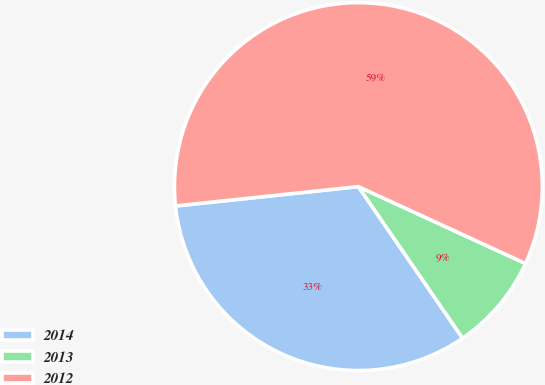Convert chart. <chart><loc_0><loc_0><loc_500><loc_500><pie_chart><fcel>2014<fcel>2013<fcel>2012<nl><fcel>32.91%<fcel>8.55%<fcel>58.55%<nl></chart> 